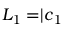Convert formula to latex. <formula><loc_0><loc_0><loc_500><loc_500>L _ { 1 } = | \boldsymbol c _ { 1 }</formula> 